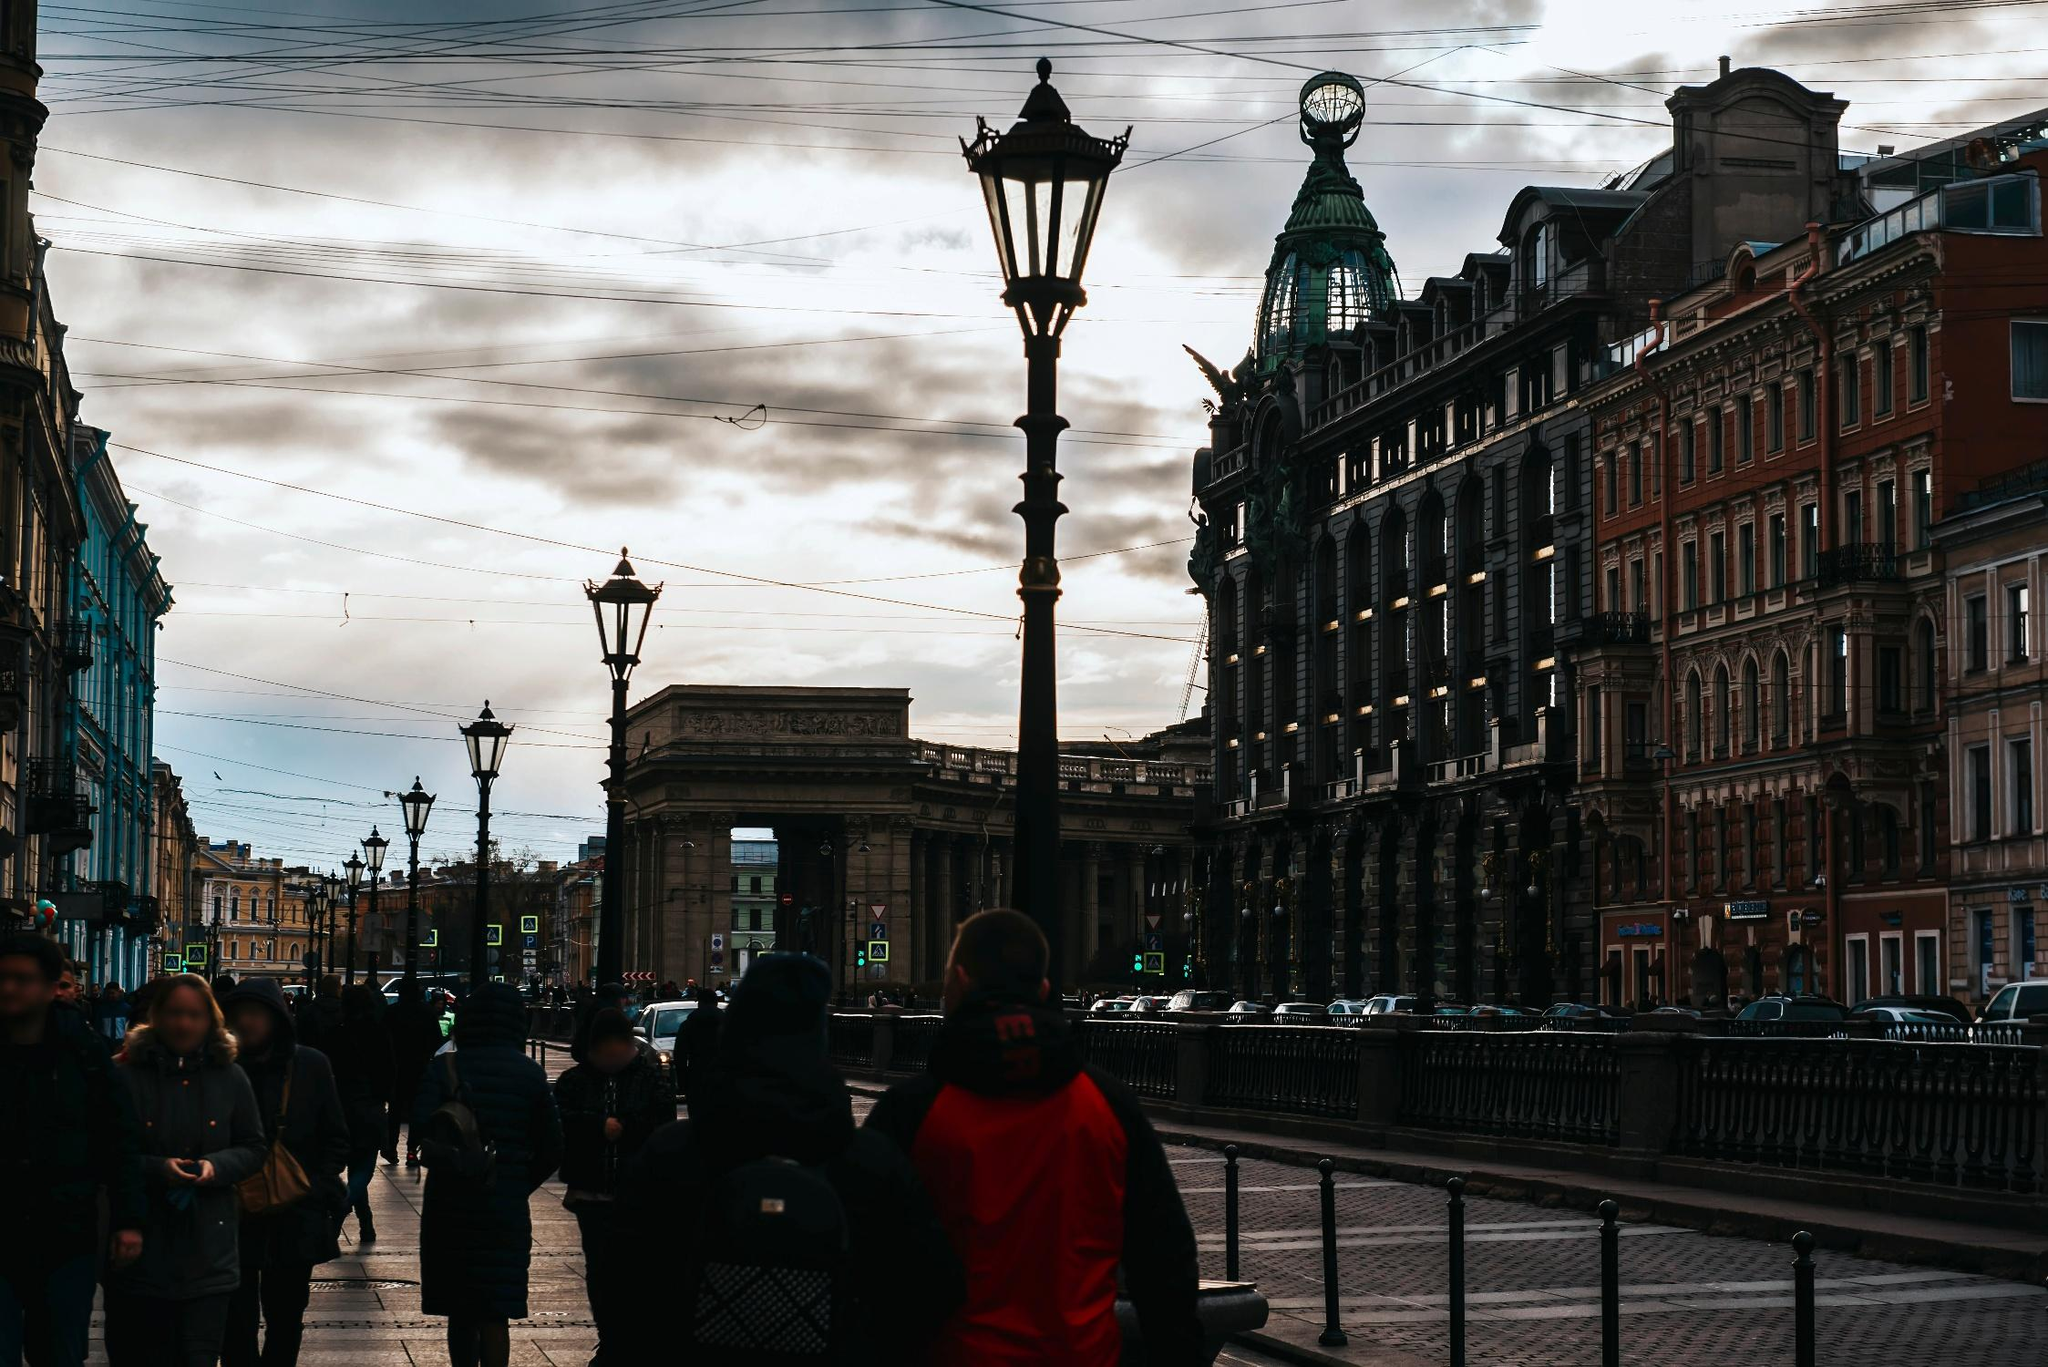What's happening in the scene?
 The image captures a bustling scene in a European city at sunset. The main focus is a street, flanked by ornate buildings of red and brown hues. The architecture is intricate, suggesting a rich history. The street is busy with several people going about their day, walking on the sidewalks. 

Vehicles are parked along the street, adding to the urban atmosphere. In the center, a large archway stands as a prominent feature, with a street lamp nearby. The sky overhead is cloudy, and the setting sun casts a warm glow over the scene, enhancing the colors of the buildings and creating a serene ambiance. Despite the absence of text or discernible signs, the image exudes a sense of a vibrant city life winding down as the day ends. 

Please note that this description is based on the visible elements in the image and does not include any speculative or inferred information. 